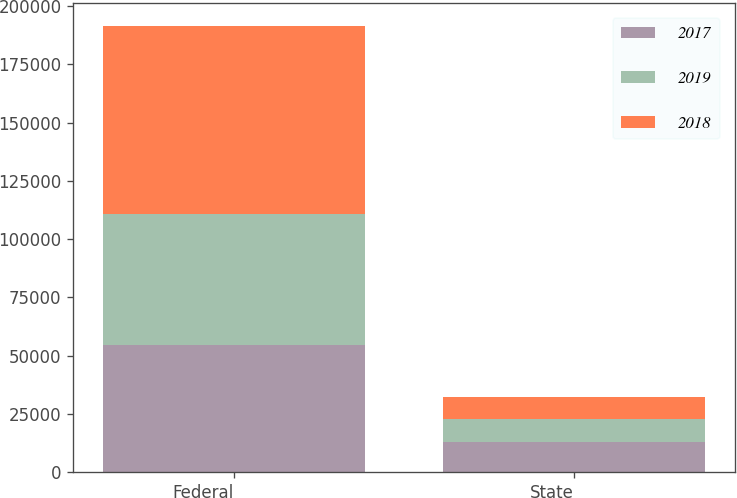Convert chart. <chart><loc_0><loc_0><loc_500><loc_500><stacked_bar_chart><ecel><fcel>Federal<fcel>State<nl><fcel>2017<fcel>54800<fcel>12946<nl><fcel>2019<fcel>56060<fcel>9948<nl><fcel>2018<fcel>80752<fcel>9469<nl></chart> 